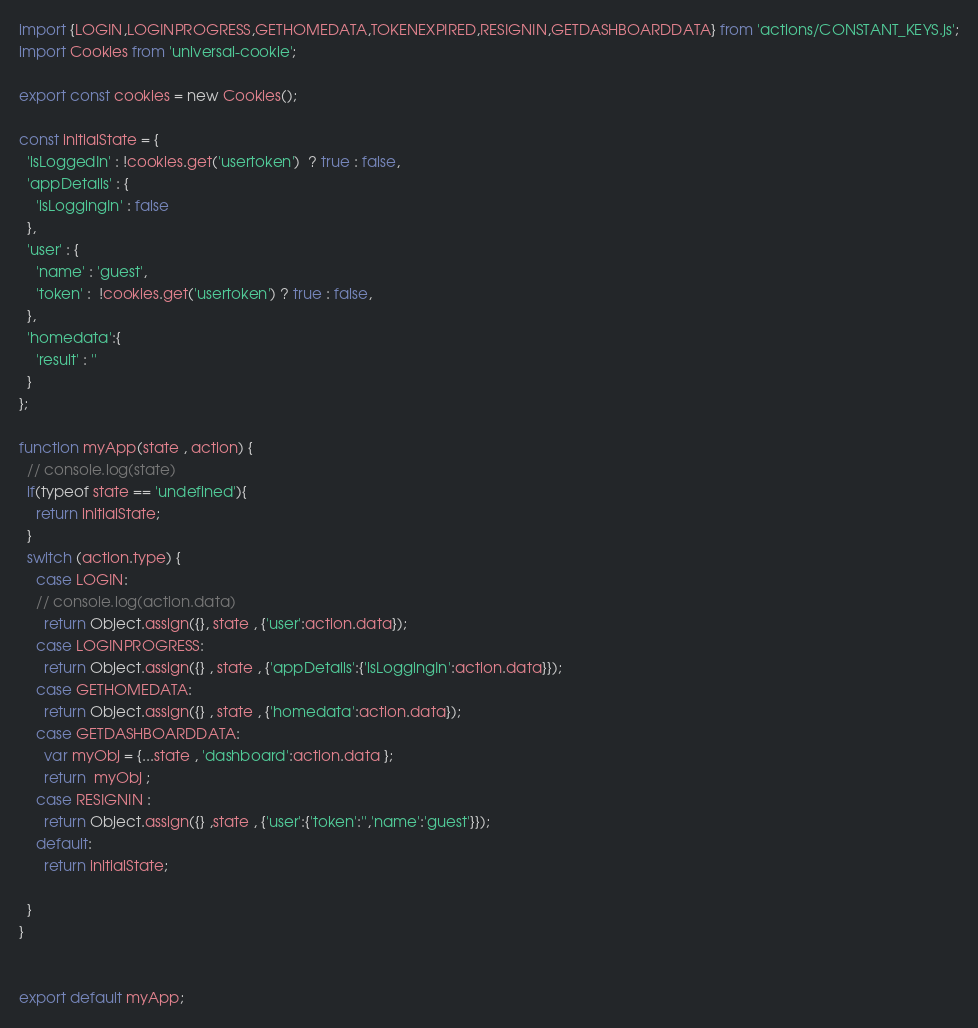<code> <loc_0><loc_0><loc_500><loc_500><_JavaScript_>import {LOGIN,LOGINPROGRESS,GETHOMEDATA,TOKENEXPIRED,RESIGNIN,GETDASHBOARDDATA} from 'actions/CONSTANT_KEYS.js';
import Cookies from 'universal-cookie';

export const cookies = new Cookies();

const initialState = {
  'isLoggedIn' : !cookies.get('usertoken')  ? true : false,
  'appDetails' : {
    'isLoggingIn' : false
  },
  'user' : {
    'name' : 'guest',
    'token' :  !cookies.get('usertoken') ? true : false,
  },
  'homedata':{
    'result' : ''
  }
};

function myApp(state , action) {
  // console.log(state)
  if(typeof state == 'undefined'){
    return initialState;
  }
  switch (action.type) {
    case LOGIN:
    // console.log(action.data)
      return Object.assign({}, state , {'user':action.data});
    case LOGINPROGRESS:
      return Object.assign({} , state , {'appDetails':{'isLoggingIn':action.data}});
    case GETHOMEDATA:
      return Object.assign({} , state , {'homedata':action.data});
    case GETDASHBOARDDATA:
      var myObj = {...state , 'dashboard':action.data };
      return  myObj ;
    case RESIGNIN :
      return Object.assign({} ,state , {'user':{'token':'','name':'guest'}});
    default:
      return initialState;

  }
}


export default myApp;
</code> 